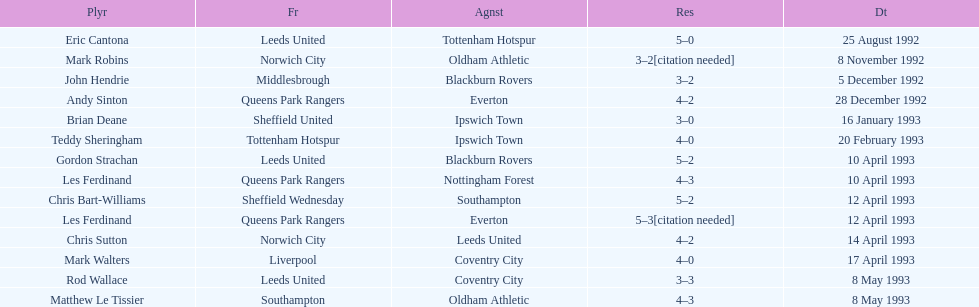How many players were for leeds united? 3. 